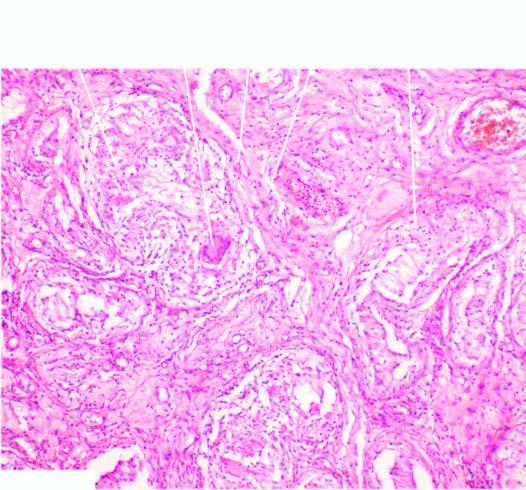re these granulomas surrounded by langhans 'giant cells and mantle of lymphocytes?
Answer the question using a single word or phrase. Yes 